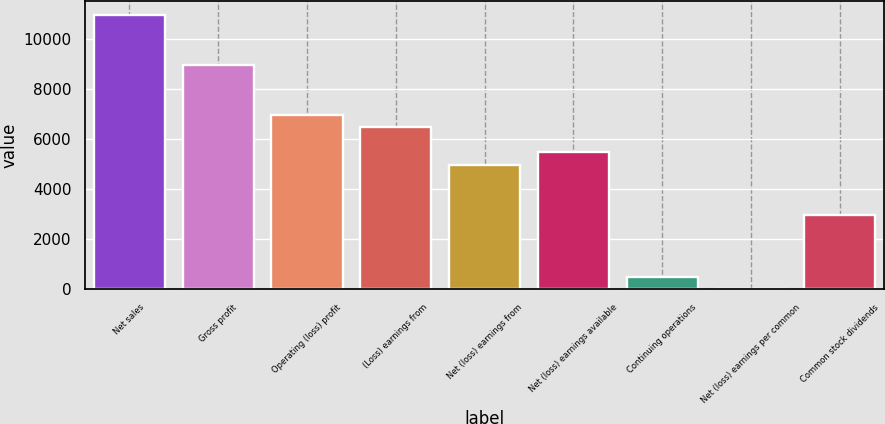Convert chart. <chart><loc_0><loc_0><loc_500><loc_500><bar_chart><fcel>Net sales<fcel>Gross profit<fcel>Operating (loss) profit<fcel>(Loss) earnings from<fcel>Net (loss) earnings from<fcel>Net (loss) earnings available<fcel>Continuing operations<fcel>Net (loss) earnings per common<fcel>Common stock dividends<nl><fcel>10968<fcel>8973.99<fcel>6979.99<fcel>6481.49<fcel>4985.99<fcel>5484.49<fcel>499.49<fcel>0.99<fcel>2991.99<nl></chart> 